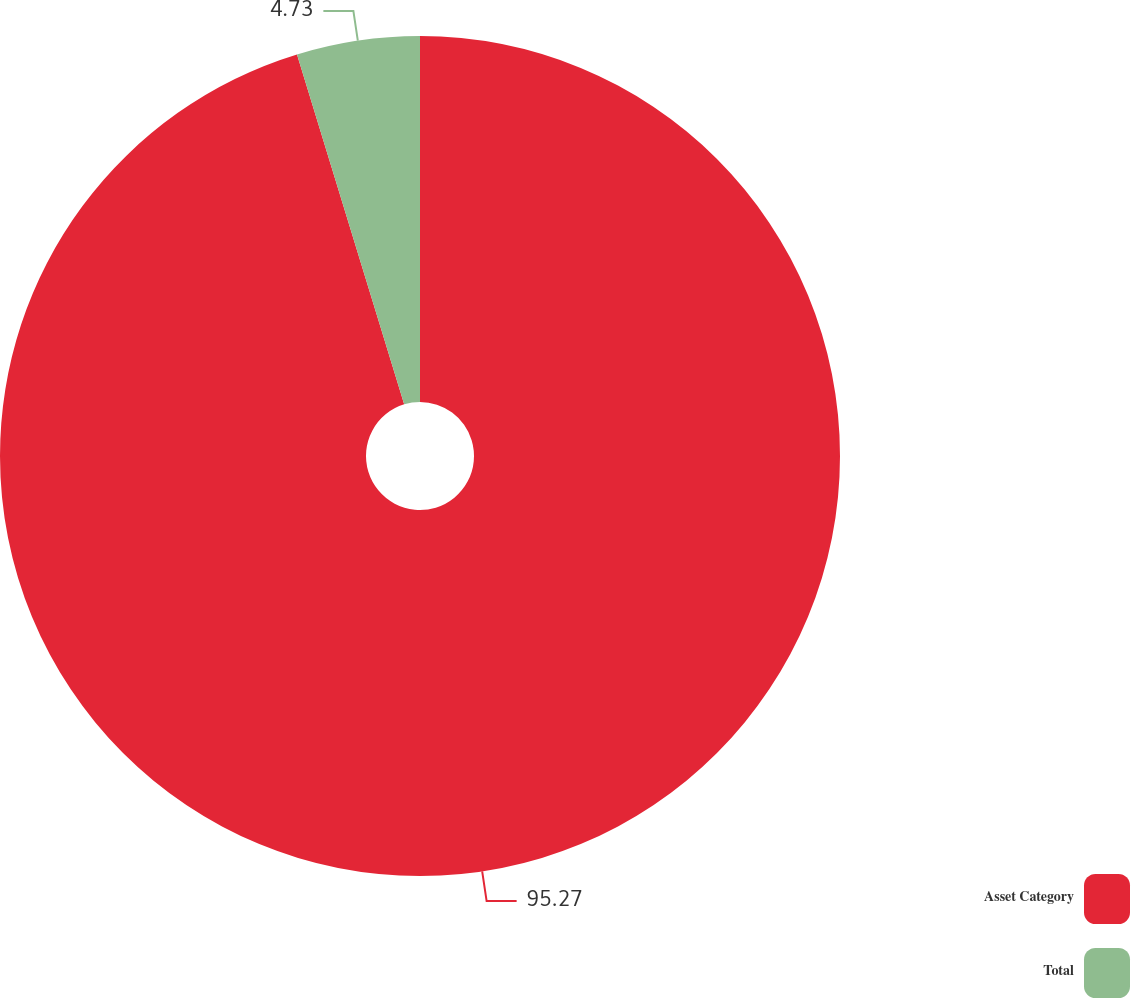<chart> <loc_0><loc_0><loc_500><loc_500><pie_chart><fcel>Asset Category<fcel>Total<nl><fcel>95.27%<fcel>4.73%<nl></chart> 